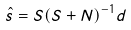<formula> <loc_0><loc_0><loc_500><loc_500>\hat { s } = S ( S + N ) ^ { - 1 } d</formula> 